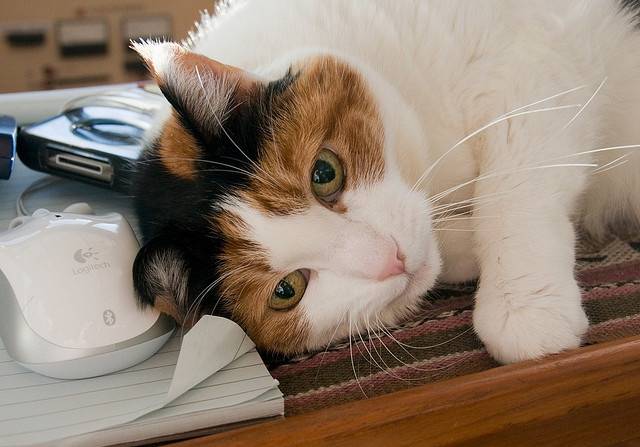Describe the objects in this image and their specific colors. I can see cat in gray, darkgray, black, and lightgray tones, mouse in gray, lightgray, and darkgray tones, book in gray and darkgray tones, and cell phone in gray, black, lavender, and darkgray tones in this image. 